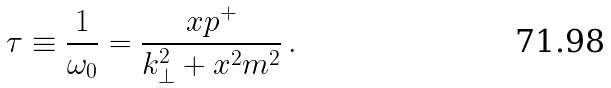Convert formula to latex. <formula><loc_0><loc_0><loc_500><loc_500>\tau \equiv \frac { 1 } { \omega _ { 0 } } = \frac { x p ^ { + } } { { k } _ { \perp } ^ { 2 } + x ^ { 2 } m ^ { 2 } } \, .</formula> 